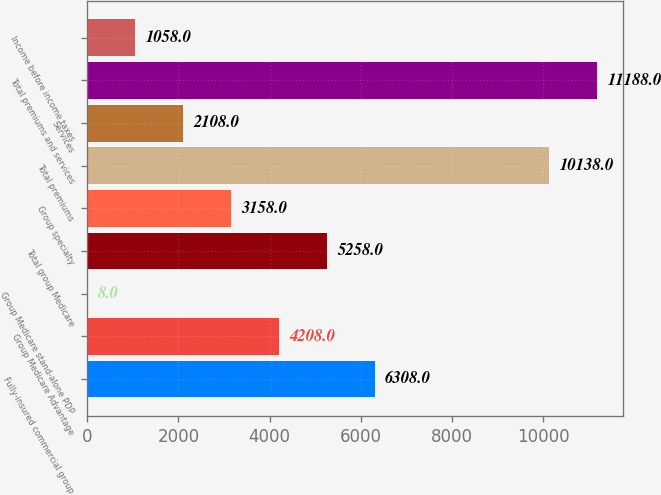<chart> <loc_0><loc_0><loc_500><loc_500><bar_chart><fcel>Fully-insured commercial group<fcel>Group Medicare Advantage<fcel>Group Medicare stand-alone PDP<fcel>Total group Medicare<fcel>Group specialty<fcel>Total premiums<fcel>Services<fcel>Total premiums and services<fcel>Income before income taxes<nl><fcel>6308<fcel>4208<fcel>8<fcel>5258<fcel>3158<fcel>10138<fcel>2108<fcel>11188<fcel>1058<nl></chart> 